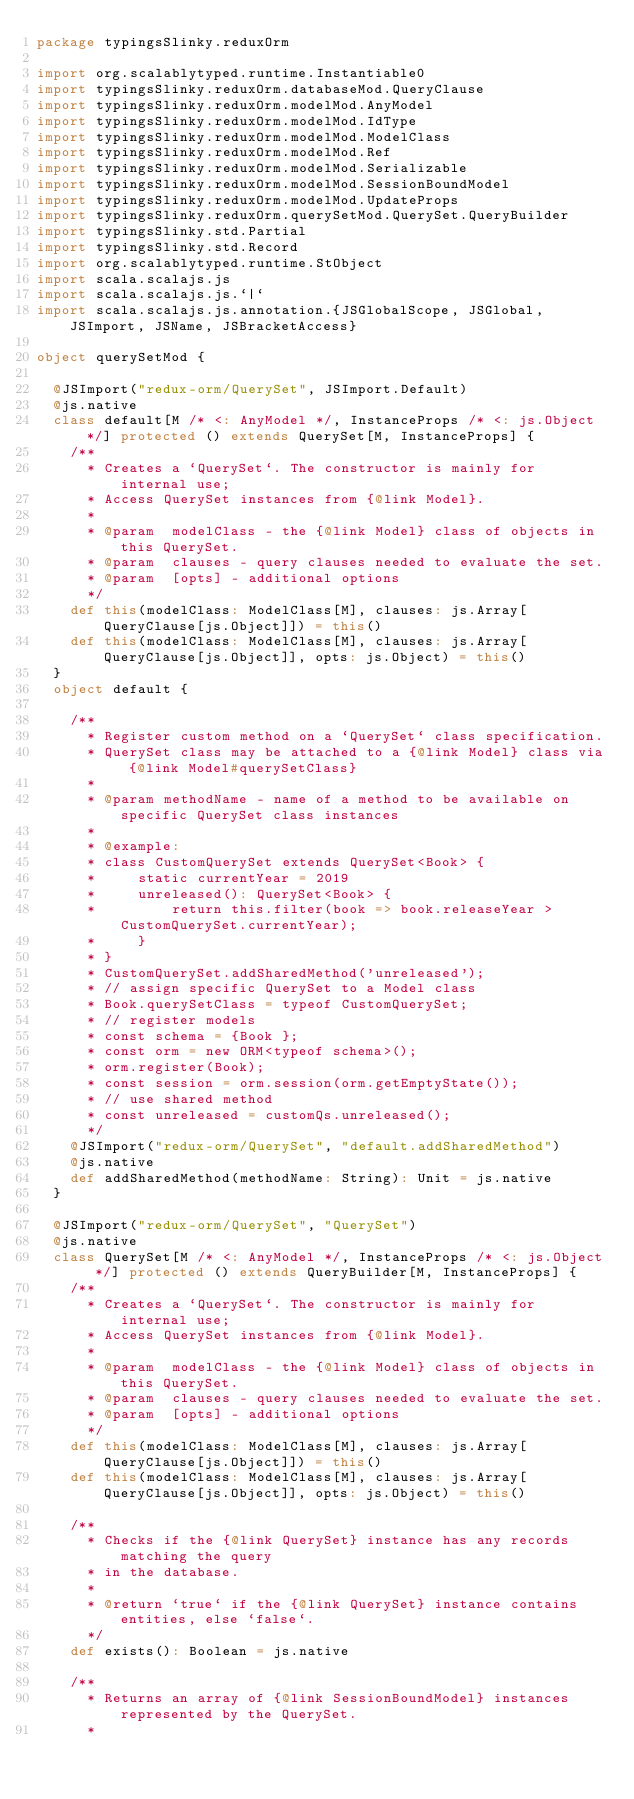Convert code to text. <code><loc_0><loc_0><loc_500><loc_500><_Scala_>package typingsSlinky.reduxOrm

import org.scalablytyped.runtime.Instantiable0
import typingsSlinky.reduxOrm.databaseMod.QueryClause
import typingsSlinky.reduxOrm.modelMod.AnyModel
import typingsSlinky.reduxOrm.modelMod.IdType
import typingsSlinky.reduxOrm.modelMod.ModelClass
import typingsSlinky.reduxOrm.modelMod.Ref
import typingsSlinky.reduxOrm.modelMod.Serializable
import typingsSlinky.reduxOrm.modelMod.SessionBoundModel
import typingsSlinky.reduxOrm.modelMod.UpdateProps
import typingsSlinky.reduxOrm.querySetMod.QuerySet.QueryBuilder
import typingsSlinky.std.Partial
import typingsSlinky.std.Record
import org.scalablytyped.runtime.StObject
import scala.scalajs.js
import scala.scalajs.js.`|`
import scala.scalajs.js.annotation.{JSGlobalScope, JSGlobal, JSImport, JSName, JSBracketAccess}

object querySetMod {
  
  @JSImport("redux-orm/QuerySet", JSImport.Default)
  @js.native
  class default[M /* <: AnyModel */, InstanceProps /* <: js.Object */] protected () extends QuerySet[M, InstanceProps] {
    /**
      * Creates a `QuerySet`. The constructor is mainly for internal use;
      * Access QuerySet instances from {@link Model}.
      *
      * @param  modelClass - the {@link Model} class of objects in this QuerySet.
      * @param  clauses - query clauses needed to evaluate the set.
      * @param  [opts] - additional options
      */
    def this(modelClass: ModelClass[M], clauses: js.Array[QueryClause[js.Object]]) = this()
    def this(modelClass: ModelClass[M], clauses: js.Array[QueryClause[js.Object]], opts: js.Object) = this()
  }
  object default {
    
    /**
      * Register custom method on a `QuerySet` class specification.
      * QuerySet class may be attached to a {@link Model} class via {@link Model#querySetClass}
      *
      * @param methodName - name of a method to be available on specific QuerySet class instances
      *
      * @example:
      * class CustomQuerySet extends QuerySet<Book> {
      *     static currentYear = 2019
      *     unreleased(): QuerySet<Book> {
      *         return this.filter(book => book.releaseYear > CustomQuerySet.currentYear);
      *     }
      * }
      * CustomQuerySet.addSharedMethod('unreleased');
      * // assign specific QuerySet to a Model class
      * Book.querySetClass = typeof CustomQuerySet;
      * // register models
      * const schema = {Book };
      * const orm = new ORM<typeof schema>();
      * orm.register(Book);
      * const session = orm.session(orm.getEmptyState());
      * // use shared method
      * const unreleased = customQs.unreleased();
      */
    @JSImport("redux-orm/QuerySet", "default.addSharedMethod")
    @js.native
    def addSharedMethod(methodName: String): Unit = js.native
  }
  
  @JSImport("redux-orm/QuerySet", "QuerySet")
  @js.native
  class QuerySet[M /* <: AnyModel */, InstanceProps /* <: js.Object */] protected () extends QueryBuilder[M, InstanceProps] {
    /**
      * Creates a `QuerySet`. The constructor is mainly for internal use;
      * Access QuerySet instances from {@link Model}.
      *
      * @param  modelClass - the {@link Model} class of objects in this QuerySet.
      * @param  clauses - query clauses needed to evaluate the set.
      * @param  [opts] - additional options
      */
    def this(modelClass: ModelClass[M], clauses: js.Array[QueryClause[js.Object]]) = this()
    def this(modelClass: ModelClass[M], clauses: js.Array[QueryClause[js.Object]], opts: js.Object) = this()
    
    /**
      * Checks if the {@link QuerySet} instance has any records matching the query
      * in the database.
      *
      * @return `true` if the {@link QuerySet} instance contains entities, else `false`.
      */
    def exists(): Boolean = js.native
    
    /**
      * Returns an array of {@link SessionBoundModel} instances represented by the QuerySet.
      *</code> 